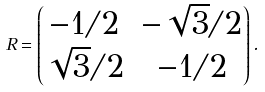<formula> <loc_0><loc_0><loc_500><loc_500>R = \begin{pmatrix} - 1 / 2 & - \sqrt { 3 } / 2 \\ \sqrt { 3 } / 2 & - 1 / 2 \end{pmatrix} .</formula> 